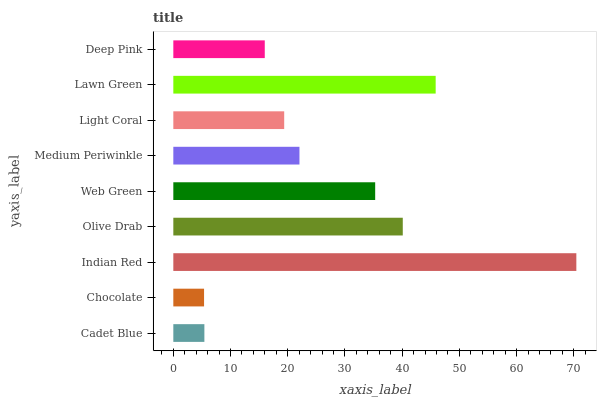Is Chocolate the minimum?
Answer yes or no. Yes. Is Indian Red the maximum?
Answer yes or no. Yes. Is Indian Red the minimum?
Answer yes or no. No. Is Chocolate the maximum?
Answer yes or no. No. Is Indian Red greater than Chocolate?
Answer yes or no. Yes. Is Chocolate less than Indian Red?
Answer yes or no. Yes. Is Chocolate greater than Indian Red?
Answer yes or no. No. Is Indian Red less than Chocolate?
Answer yes or no. No. Is Medium Periwinkle the high median?
Answer yes or no. Yes. Is Medium Periwinkle the low median?
Answer yes or no. Yes. Is Indian Red the high median?
Answer yes or no. No. Is Light Coral the low median?
Answer yes or no. No. 